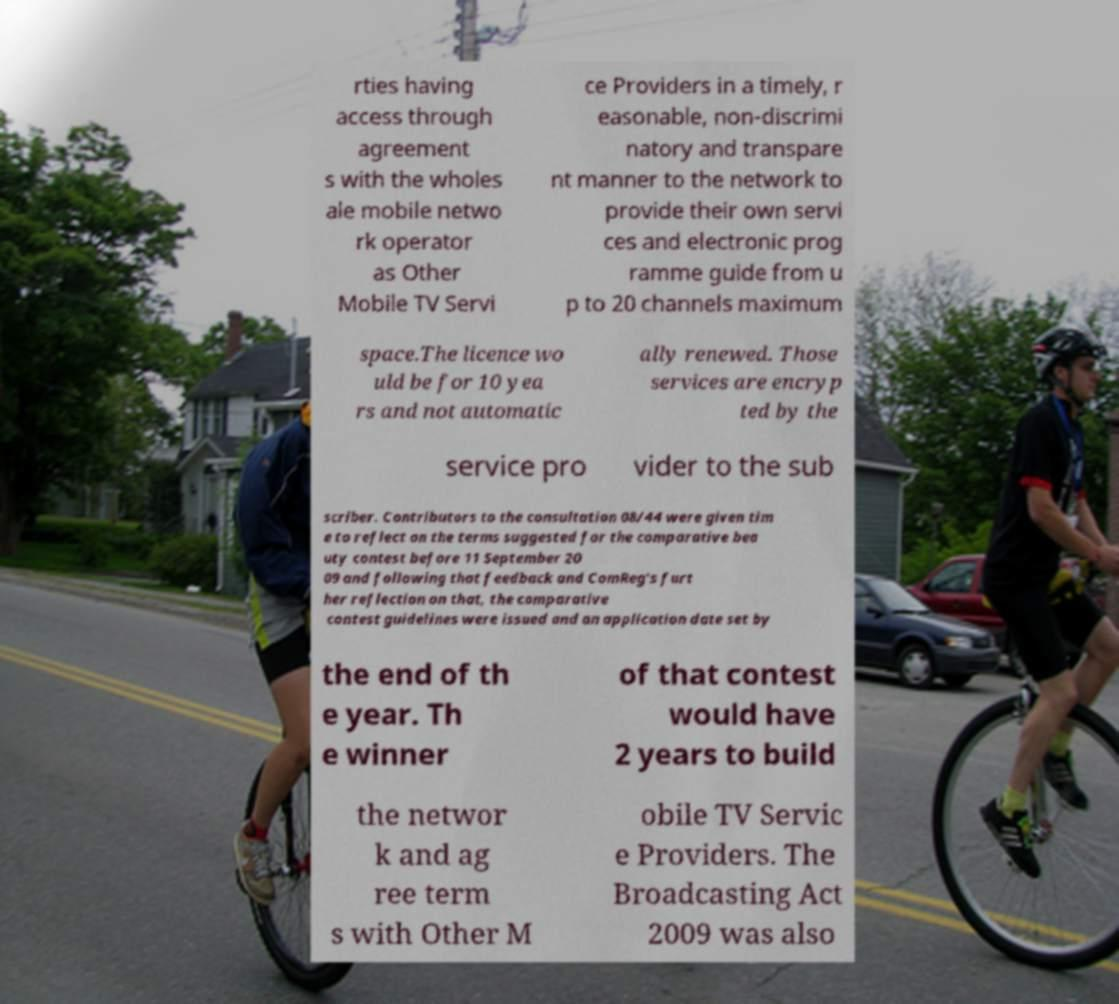Could you assist in decoding the text presented in this image and type it out clearly? rties having access through agreement s with the wholes ale mobile netwo rk operator as Other Mobile TV Servi ce Providers in a timely, r easonable, non-discrimi natory and transpare nt manner to the network to provide their own servi ces and electronic prog ramme guide from u p to 20 channels maximum space.The licence wo uld be for 10 yea rs and not automatic ally renewed. Those services are encryp ted by the service pro vider to the sub scriber. Contributors to the consultation 08/44 were given tim e to reflect on the terms suggested for the comparative bea uty contest before 11 September 20 09 and following that feedback and ComReg's furt her reflection on that, the comparative contest guidelines were issued and an application date set by the end of th e year. Th e winner of that contest would have 2 years to build the networ k and ag ree term s with Other M obile TV Servic e Providers. The Broadcasting Act 2009 was also 